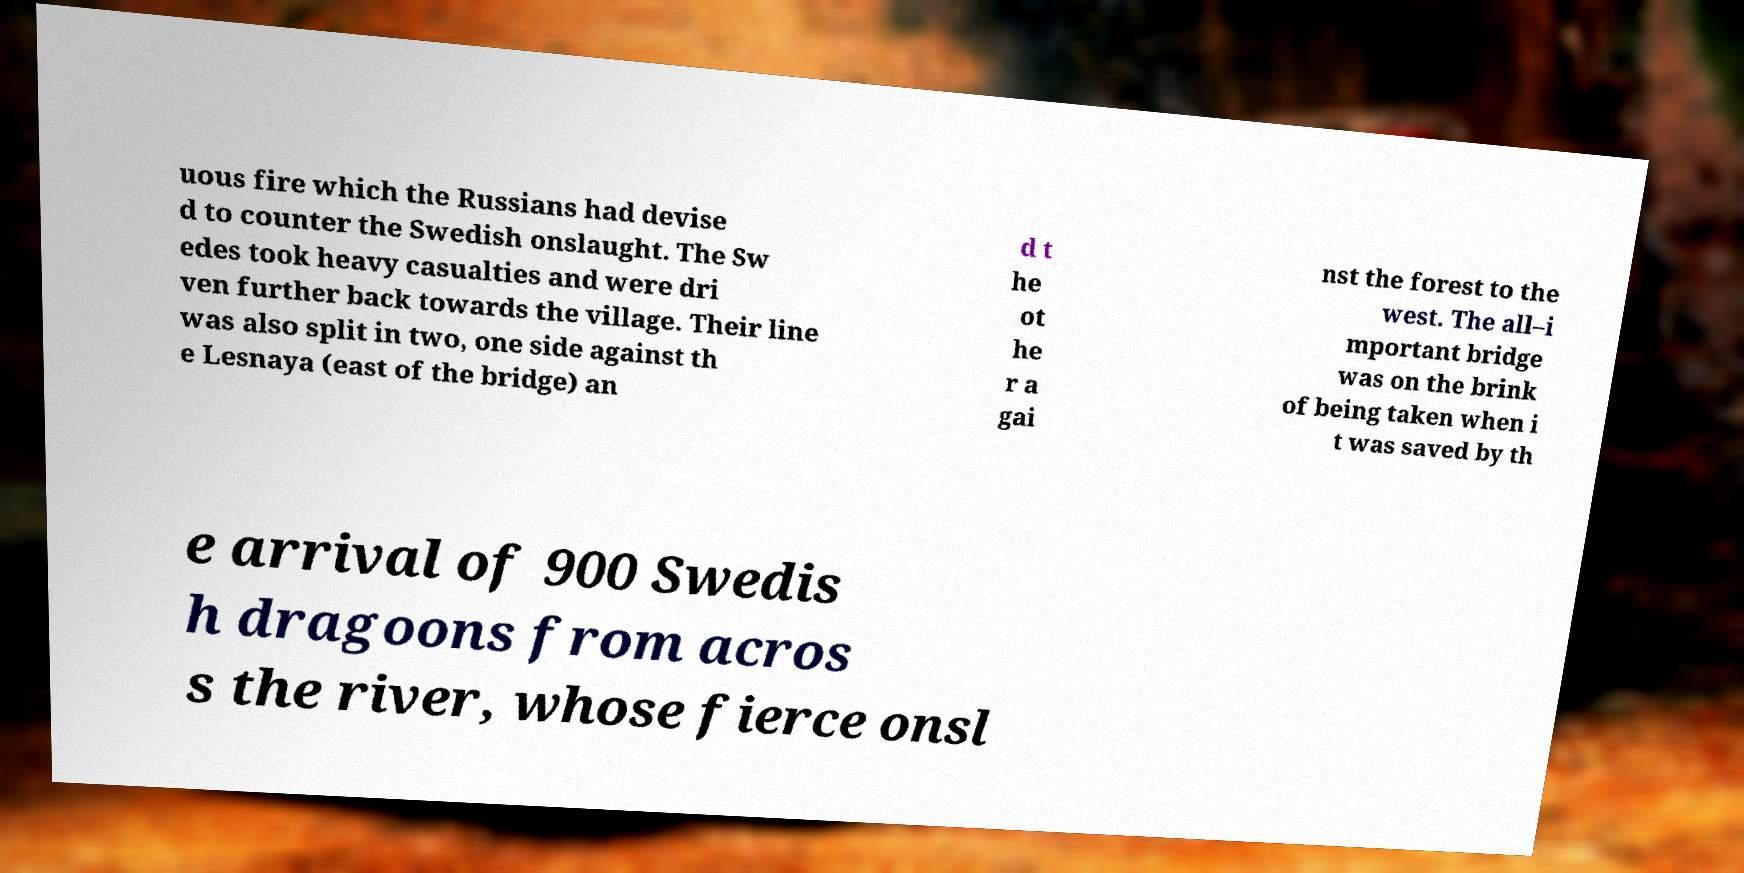There's text embedded in this image that I need extracted. Can you transcribe it verbatim? uous fire which the Russians had devise d to counter the Swedish onslaught. The Sw edes took heavy casualties and were dri ven further back towards the village. Their line was also split in two, one side against th e Lesnaya (east of the bridge) an d t he ot he r a gai nst the forest to the west. The all–i mportant bridge was on the brink of being taken when i t was saved by th e arrival of 900 Swedis h dragoons from acros s the river, whose fierce onsl 